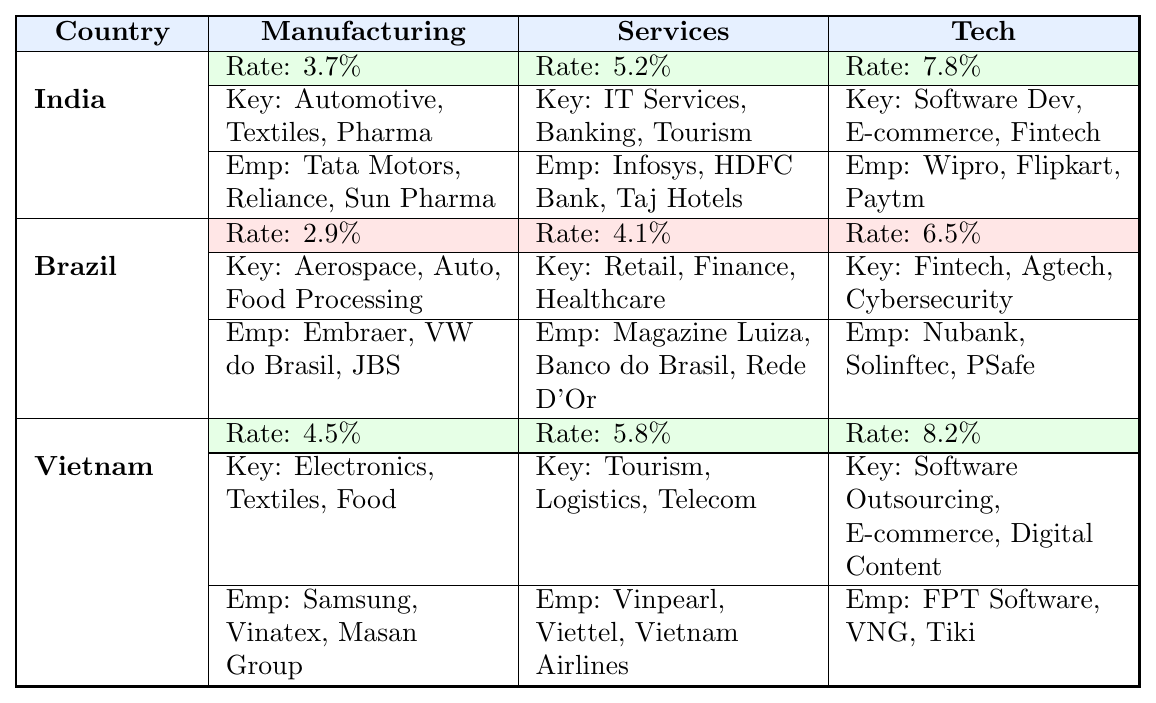What is the annual job creation rate for the tech sector in India? The table shows that the annual job creation rate for the tech sector in India is 7.8%.
Answer: 7.8% Which country has the highest annual job creation rate in manufacturing? Comparing the rates in the manufacturing sector, India has 3.7%, Brazil has 2.9%, and Vietnam has 4.5%. The highest is Vietnam with 4.5%.
Answer: Vietnam What are the major employers in Brazil's services sector? The table lists the major employers in Brazil's services sector as Magazine Luiza, Banco do Brasil, and Rede D'Or São Luiz.
Answer: Magazine Luiza, Banco do Brasil, Rede D'Or São Luiz Is the annual job creation rate in the services sector higher in Brazil or Vietnam? For Brazil, the services sector rate is 4.1%, while for Vietnam it is 5.8%. Since 5.8% is greater than 4.1%, Vietnam has a higher rate.
Answer: Vietnam What is the difference in annual job creation rates between the manufacturing sector in India and the tech sector in Brazil? India's manufacturing rate is 3.7%, and Brazil's tech rate is 6.5%. The difference is 6.5% - 3.7% = 2.8%.
Answer: 2.8% Which sector has a higher job creation rate in Vietnam: services or tech? The job creation rate for the services sector in Vietnam is 5.8% and for tech, it is 8.2%. Since 8.2% is greater than 5.8%, tech has the higher rate.
Answer: Tech What is the average annual job creation rate across all sectors for Brazil? The rates for Brazil are: Manufacturing 2.9%, Services 4.1%, Tech 6.5%. To find the average: (2.9 + 4.1 + 6.5) / 3 = 4.5%.
Answer: 4.5% Which two countries have the same rate of annual job creation in the services sector? India's services sector has 5.2% and Brazil has 4.1%, while Vietnam has 5.8%. Therefore, there are no two countries with the same rate.
Answer: No What is the combined manufacturing job creation rate of India and Vietnam? India's manufacturing rate is 3.7% and Vietnam's is 4.5%. The combined rate is 3.7% + 4.5% = 8.2%.
Answer: 8.2% Which sector in India has the lowest annual job creation rate? Comparing the sectors in India: Manufacturing is 3.7%, Services is 5.2%, and Tech is 7.8%. The lowest is Manufacturing at 3.7%.
Answer: Manufacturing 